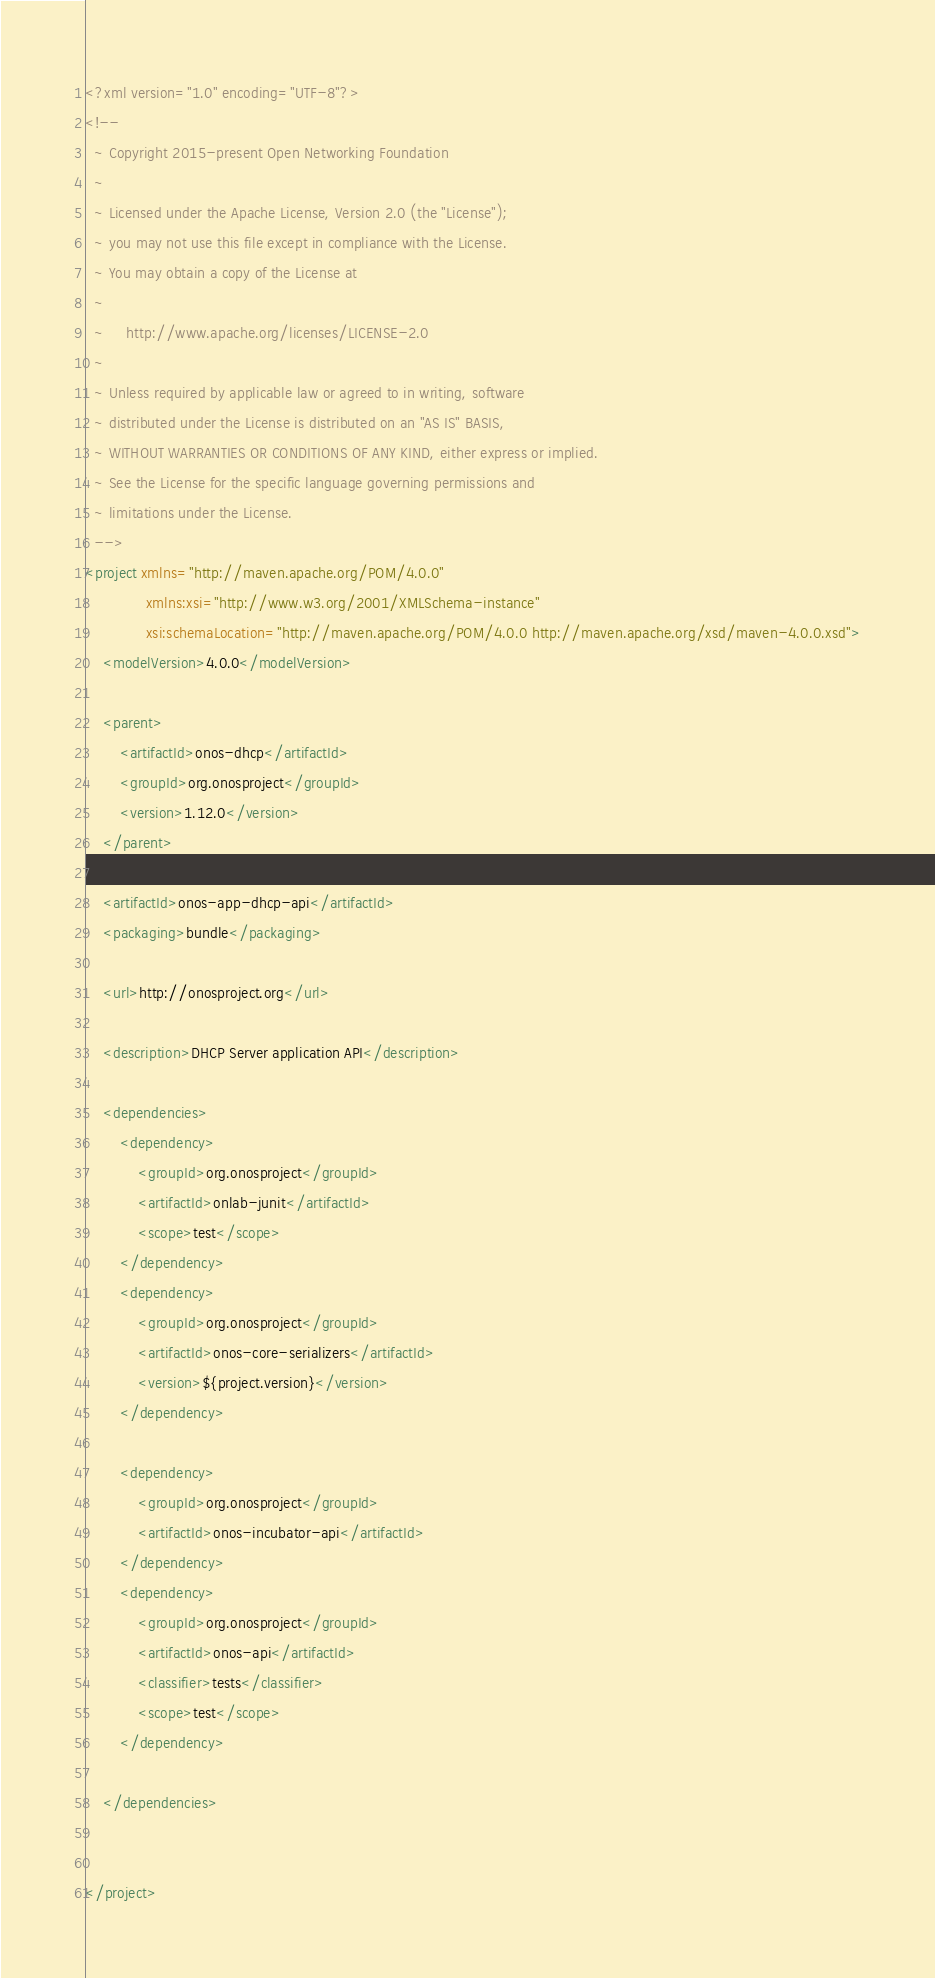<code> <loc_0><loc_0><loc_500><loc_500><_XML_><?xml version="1.0" encoding="UTF-8"?>
<!--
  ~ Copyright 2015-present Open Networking Foundation
  ~
  ~ Licensed under the Apache License, Version 2.0 (the "License");
  ~ you may not use this file except in compliance with the License.
  ~ You may obtain a copy of the License at
  ~
  ~     http://www.apache.org/licenses/LICENSE-2.0
  ~
  ~ Unless required by applicable law or agreed to in writing, software
  ~ distributed under the License is distributed on an "AS IS" BASIS,
  ~ WITHOUT WARRANTIES OR CONDITIONS OF ANY KIND, either express or implied.
  ~ See the License for the specific language governing permissions and
  ~ limitations under the License.
  -->
<project xmlns="http://maven.apache.org/POM/4.0.0"
              xmlns:xsi="http://www.w3.org/2001/XMLSchema-instance"
              xsi:schemaLocation="http://maven.apache.org/POM/4.0.0 http://maven.apache.org/xsd/maven-4.0.0.xsd">
    <modelVersion>4.0.0</modelVersion>

    <parent>
        <artifactId>onos-dhcp</artifactId>
        <groupId>org.onosproject</groupId>
        <version>1.12.0</version>
    </parent>

    <artifactId>onos-app-dhcp-api</artifactId>
    <packaging>bundle</packaging>

    <url>http://onosproject.org</url>

    <description>DHCP Server application API</description>

    <dependencies>
        <dependency>
            <groupId>org.onosproject</groupId>
            <artifactId>onlab-junit</artifactId>
            <scope>test</scope>
        </dependency>
        <dependency>
            <groupId>org.onosproject</groupId>
            <artifactId>onos-core-serializers</artifactId>
            <version>${project.version}</version>
        </dependency>

        <dependency>
            <groupId>org.onosproject</groupId>
            <artifactId>onos-incubator-api</artifactId>
        </dependency>
        <dependency>
            <groupId>org.onosproject</groupId>
            <artifactId>onos-api</artifactId>
            <classifier>tests</classifier>
            <scope>test</scope>
        </dependency>

    </dependencies>


</project>
</code> 